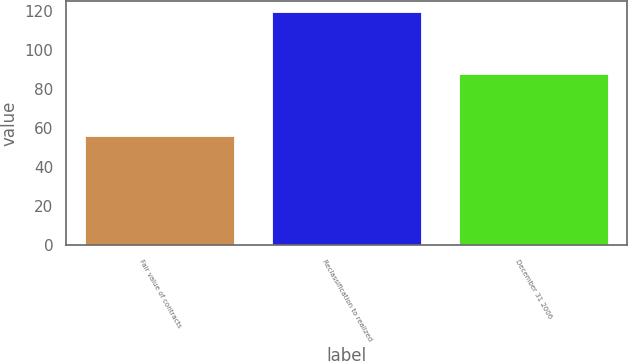Convert chart to OTSL. <chart><loc_0><loc_0><loc_500><loc_500><bar_chart><fcel>Fair value of contracts<fcel>Reclassification to realized<fcel>December 31 2006<nl><fcel>56<fcel>119.4<fcel>87.7<nl></chart> 